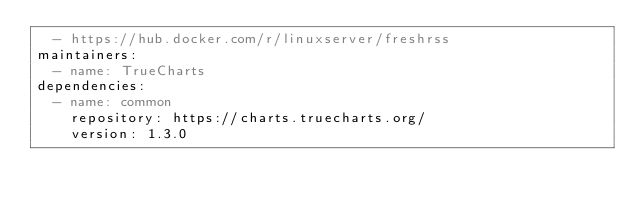<code> <loc_0><loc_0><loc_500><loc_500><_YAML_>  - https://hub.docker.com/r/linuxserver/freshrss
maintainers:
  - name: TrueCharts
dependencies:
  - name: common
    repository: https://charts.truecharts.org/
    version: 1.3.0
    
</code> 